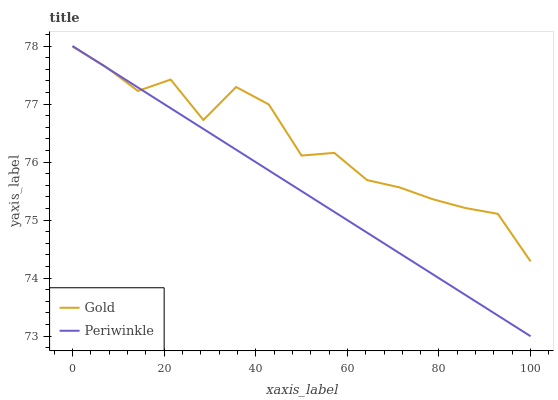Does Periwinkle have the minimum area under the curve?
Answer yes or no. Yes. Does Gold have the maximum area under the curve?
Answer yes or no. Yes. Does Gold have the minimum area under the curve?
Answer yes or no. No. Is Periwinkle the smoothest?
Answer yes or no. Yes. Is Gold the roughest?
Answer yes or no. Yes. Is Gold the smoothest?
Answer yes or no. No. Does Periwinkle have the lowest value?
Answer yes or no. Yes. Does Gold have the lowest value?
Answer yes or no. No. Does Periwinkle have the highest value?
Answer yes or no. Yes. Does Gold have the highest value?
Answer yes or no. No. Does Periwinkle intersect Gold?
Answer yes or no. Yes. Is Periwinkle less than Gold?
Answer yes or no. No. Is Periwinkle greater than Gold?
Answer yes or no. No. 